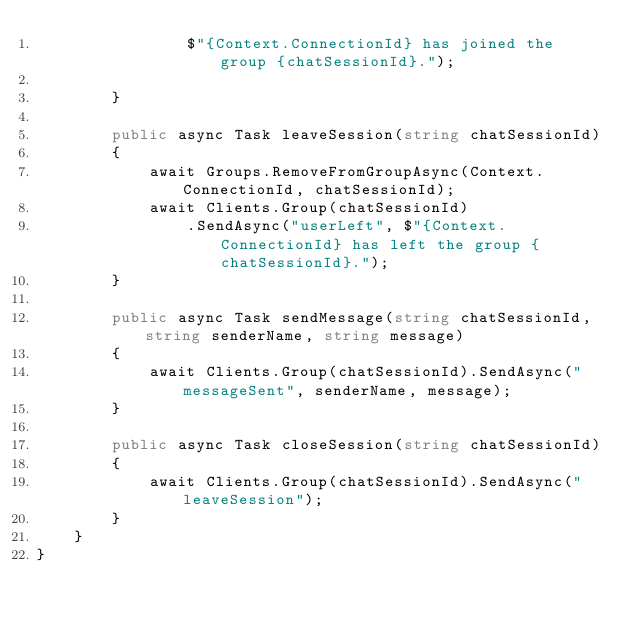<code> <loc_0><loc_0><loc_500><loc_500><_C#_>                $"{Context.ConnectionId} has joined the group {chatSessionId}.");

        }

        public async Task leaveSession(string chatSessionId)
        {
            await Groups.RemoveFromGroupAsync(Context.ConnectionId, chatSessionId);
            await Clients.Group(chatSessionId)
                .SendAsync("userLeft", $"{Context.ConnectionId} has left the group {chatSessionId}.");
        }

        public async Task sendMessage(string chatSessionId, string senderName, string message)
        {
            await Clients.Group(chatSessionId).SendAsync("messageSent", senderName, message);
        }

        public async Task closeSession(string chatSessionId)
        {
            await Clients.Group(chatSessionId).SendAsync("leaveSession");
        }
    }
}</code> 